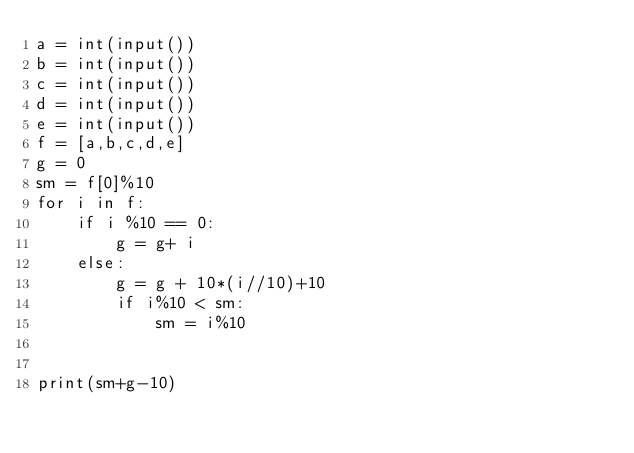<code> <loc_0><loc_0><loc_500><loc_500><_Python_>a = int(input())
b = int(input())
c = int(input())
d = int(input())
e = int(input())
f = [a,b,c,d,e]
g = 0
sm = f[0]%10
for i in f:
    if i %10 == 0:
        g = g+ i
    else:
        g = g + 10*(i//10)+10
        if i%10 < sm:
            sm = i%10


print(sm+g-10)
</code> 